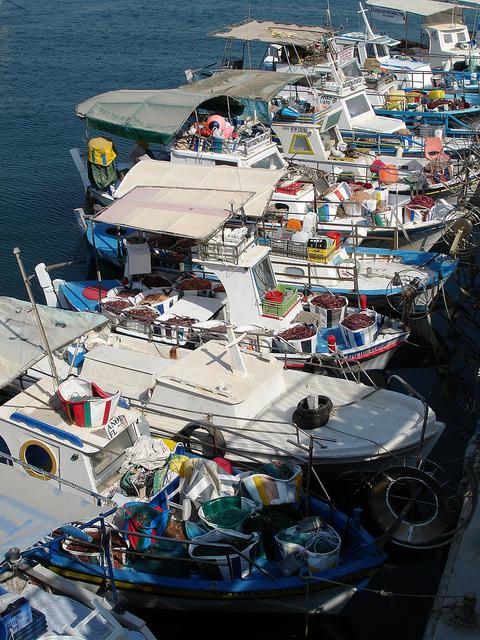Do all the boats have a cover on them?
Concise answer only. No. Does the water seem calm?
Concise answer only. Yes. How many boats can be seen?
Give a very brief answer. 10. 